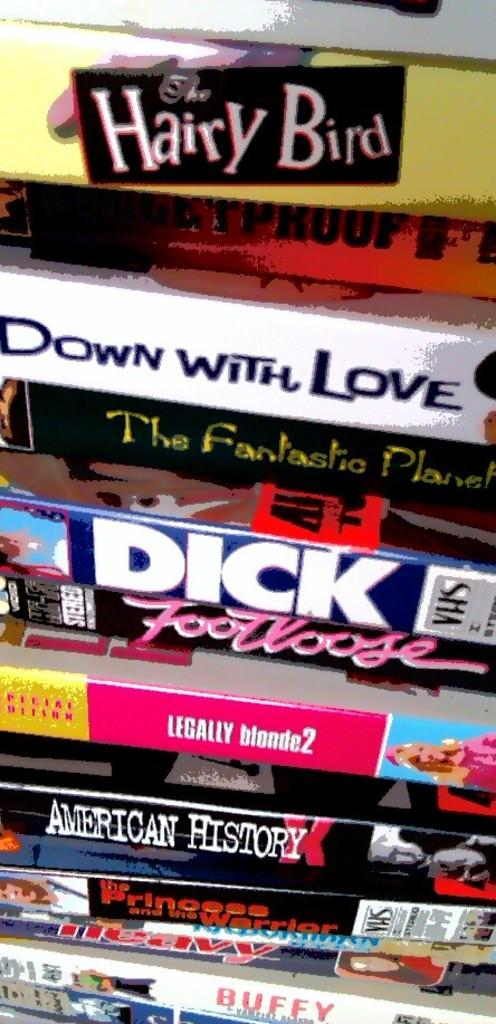<image>
Present a compact description of the photo's key features. A collection of DVD's with one of them being Footloose. 